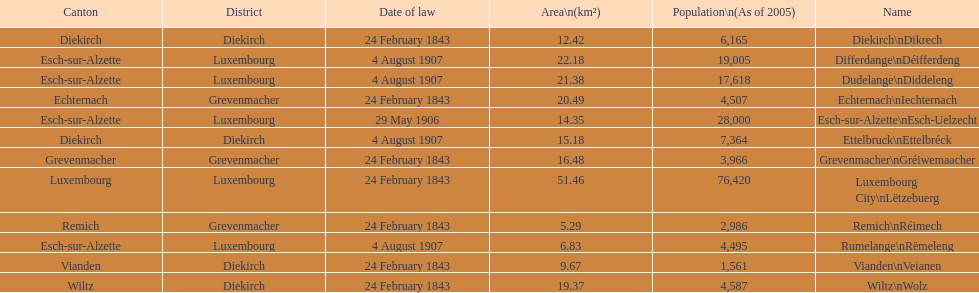What canton is the most populated? Luxembourg. 